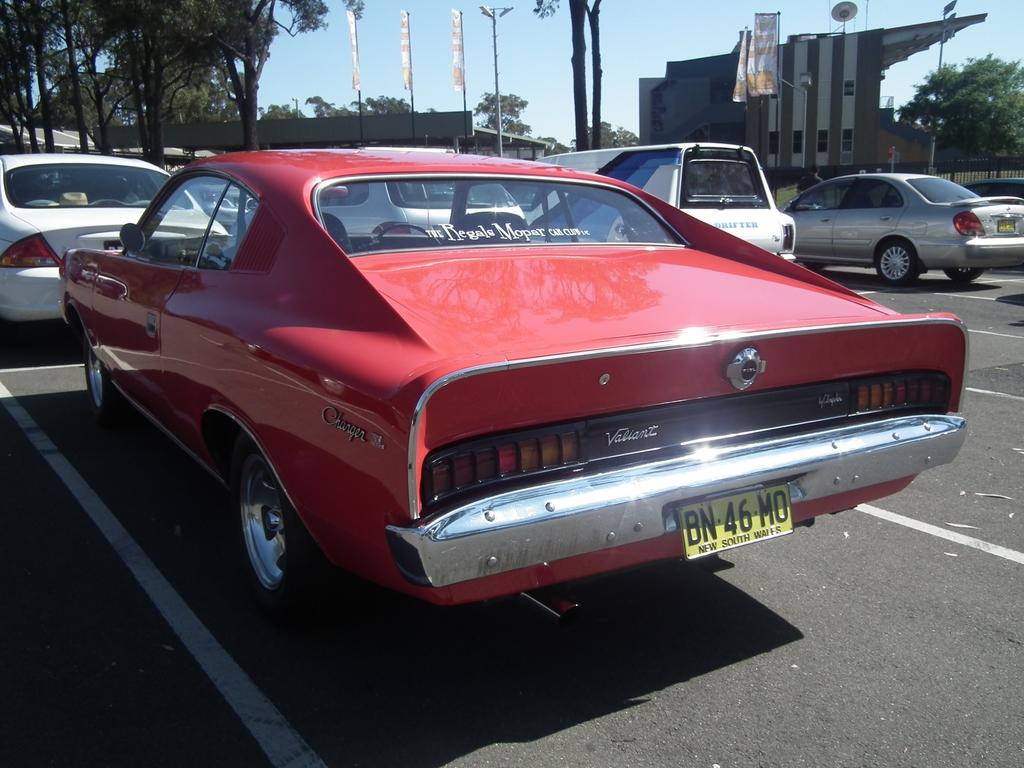What is the plate number?
Offer a terse response. Bn 46 mo. 